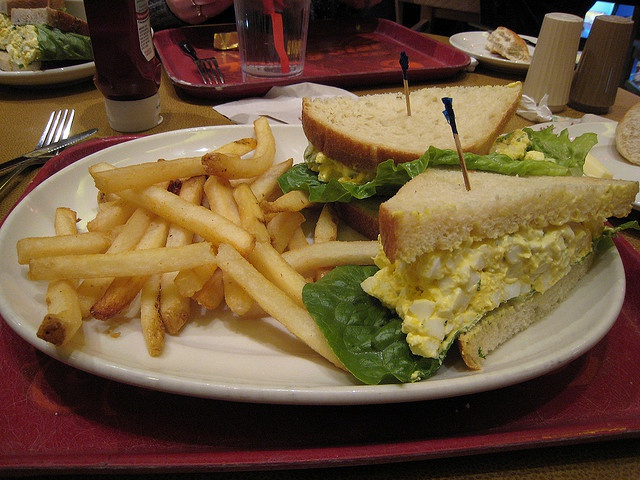Describe the objects in this image and their specific colors. I can see sandwich in gray, tan, and olive tones, sandwich in gray, tan, and maroon tones, bottle in gray, black, and maroon tones, cup in gray, black, maroon, and brown tones, and dining table in gray, olive, black, and maroon tones in this image. 